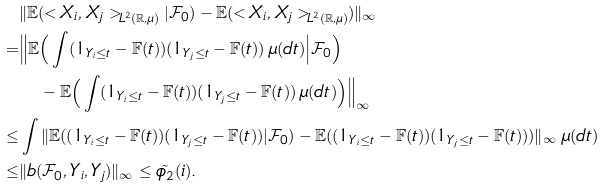Convert formula to latex. <formula><loc_0><loc_0><loc_500><loc_500>& \| \mathbb { E } ( < X _ { i } , X _ { j } > _ { L ^ { 2 } ( \mathbb { R } , \mu ) } | \mathcal { F } _ { 0 } ) - \mathbb { E } ( < X _ { i } , X _ { j } > _ { L ^ { 2 } ( \mathbb { R } , \mu ) } ) \| _ { \infty } & \\ = & \Big \| \mathbb { E } \Big ( \int ( 1 _ { Y _ { i } \leq t } - \mathbb { F } ( t ) ) ( 1 _ { Y _ { j } \leq t } - \mathbb { F } ( t ) ) \, \mu ( d t ) \Big | \mathcal { F } _ { 0 } \Big ) \\ & \quad - \mathbb { E } \Big ( \int ( 1 _ { Y _ { i } \leq t } - \mathbb { F } ( t ) ) ( 1 _ { Y _ { j } \leq t } - \mathbb { F } ( t ) ) \, \mu ( d t ) \Big ) \Big \| _ { \infty } & \\ \leq & \int \| \mathbb { E } ( ( 1 _ { Y _ { i } \leq t } - \mathbb { F } ( t ) ) ( 1 _ { Y _ { j } \leq t } - \mathbb { F } ( t ) ) | \mathcal { F } _ { 0 } ) - \mathbb { E } ( ( 1 _ { Y _ { i } \leq t } - \mathbb { F } ( t ) ) ( 1 _ { Y _ { j } \leq t } - \mathbb { F } ( t ) ) ) \| _ { \infty } \, \mu ( d t ) & \\ \leq & \| b ( \mathcal { F } _ { 0 } , Y _ { i } , Y _ { j } ) \| _ { \infty } \leq \tilde { \phi _ { 2 } } ( i ) . &</formula> 